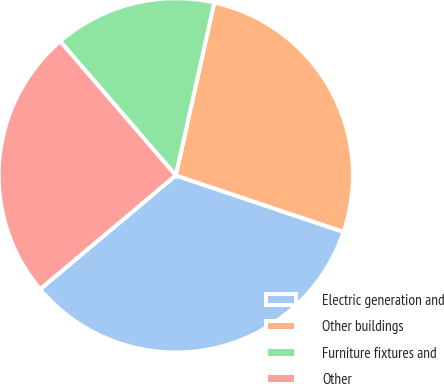Convert chart to OTSL. <chart><loc_0><loc_0><loc_500><loc_500><pie_chart><fcel>Electric generation and<fcel>Other buildings<fcel>Furniture fixtures and<fcel>Other<nl><fcel>33.72%<fcel>26.68%<fcel>14.81%<fcel>24.79%<nl></chart> 